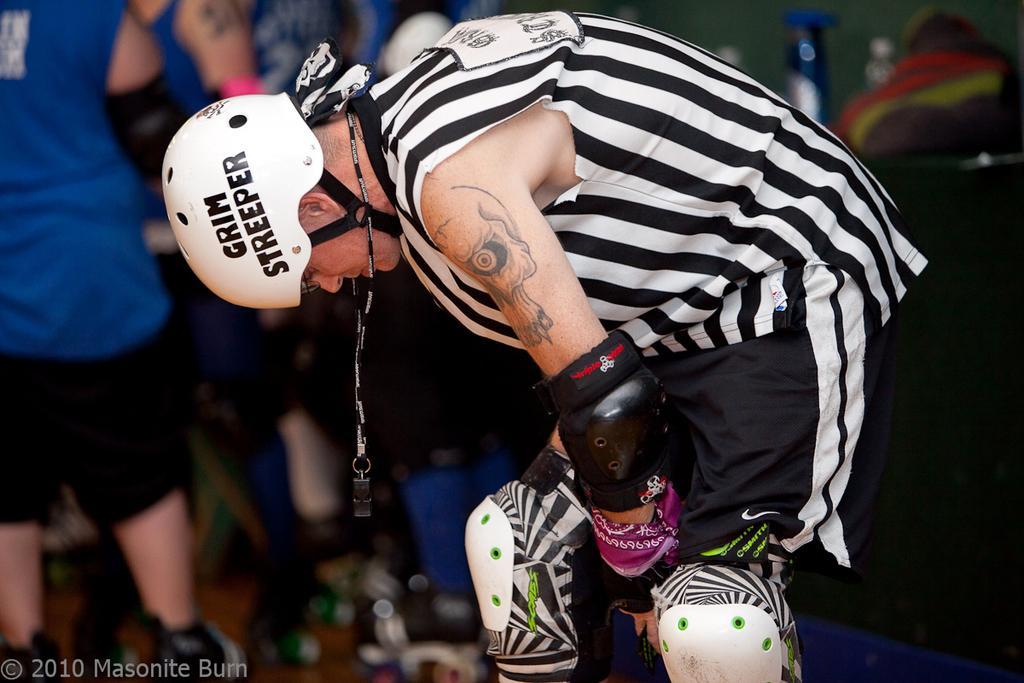Please provide a concise description of this image. In front of the picture, we see a man in white and black T-shirt is standing. He is wearing a white helmet. Behind him, we see many people in blue T-shirts are standing. In the background, it is blurred. 